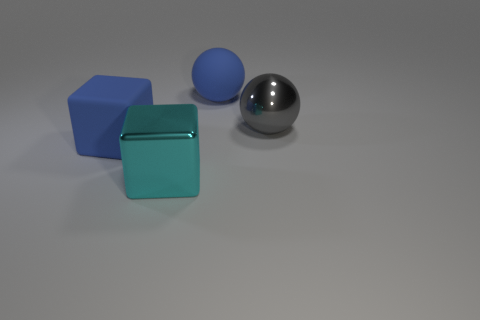Is the material of the big blue cube the same as the big cyan block?
Give a very brief answer. No. There is a cube that is the same color as the large matte sphere; what is its size?
Make the answer very short. Large. Is there a brown cylinder made of the same material as the gray object?
Make the answer very short. No. There is a big matte thing on the right side of the big rubber object to the left of the blue object behind the big gray metallic sphere; what color is it?
Offer a very short reply. Blue. What number of purple objects are either rubber things or rubber cubes?
Offer a terse response. 0. How many other big gray metallic things have the same shape as the big gray thing?
Make the answer very short. 0. There is a gray object that is the same size as the matte sphere; what shape is it?
Offer a very short reply. Sphere. There is a large gray ball; are there any big blue rubber cubes in front of it?
Your response must be concise. Yes. Are there any things that are behind the metallic block left of the metallic sphere?
Make the answer very short. Yes. Is the number of large cyan objects that are in front of the cyan shiny object less than the number of objects in front of the gray sphere?
Offer a very short reply. Yes. 